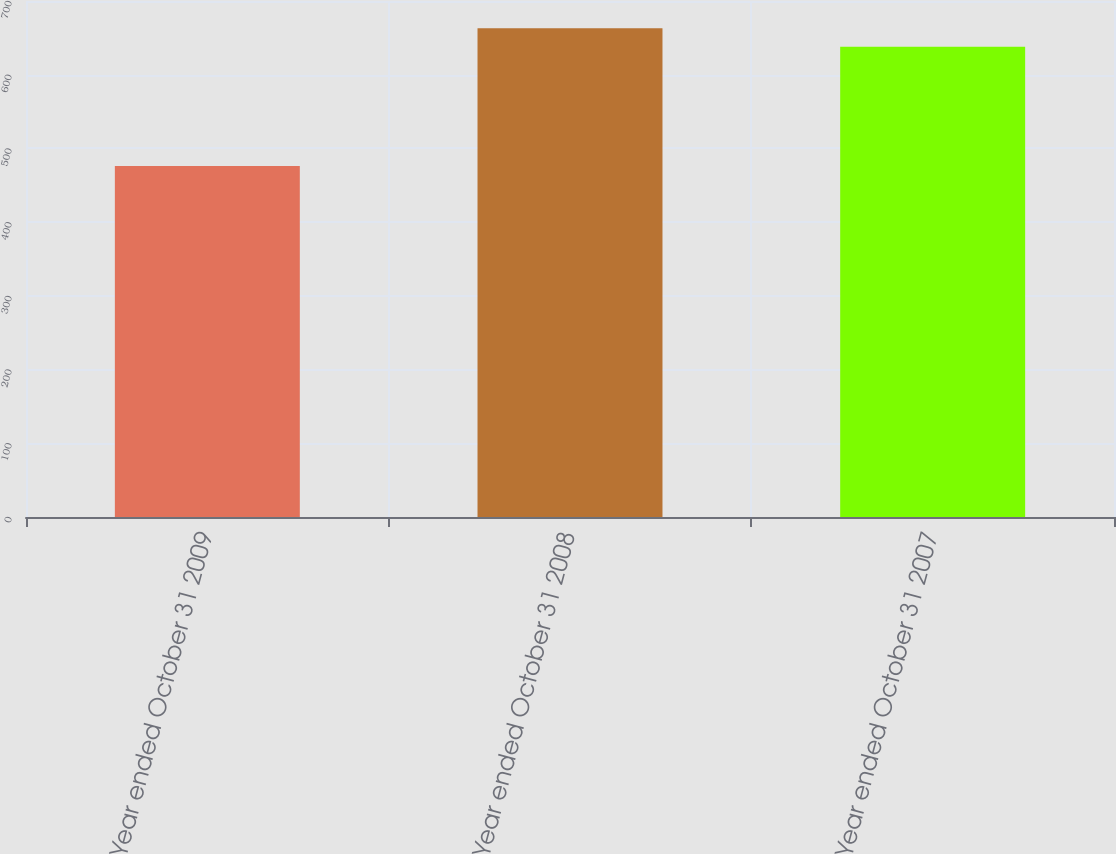<chart> <loc_0><loc_0><loc_500><loc_500><bar_chart><fcel>Year ended October 31 2009<fcel>Year ended October 31 2008<fcel>Year ended October 31 2007<nl><fcel>476<fcel>663<fcel>638<nl></chart> 